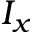<formula> <loc_0><loc_0><loc_500><loc_500>I _ { x }</formula> 